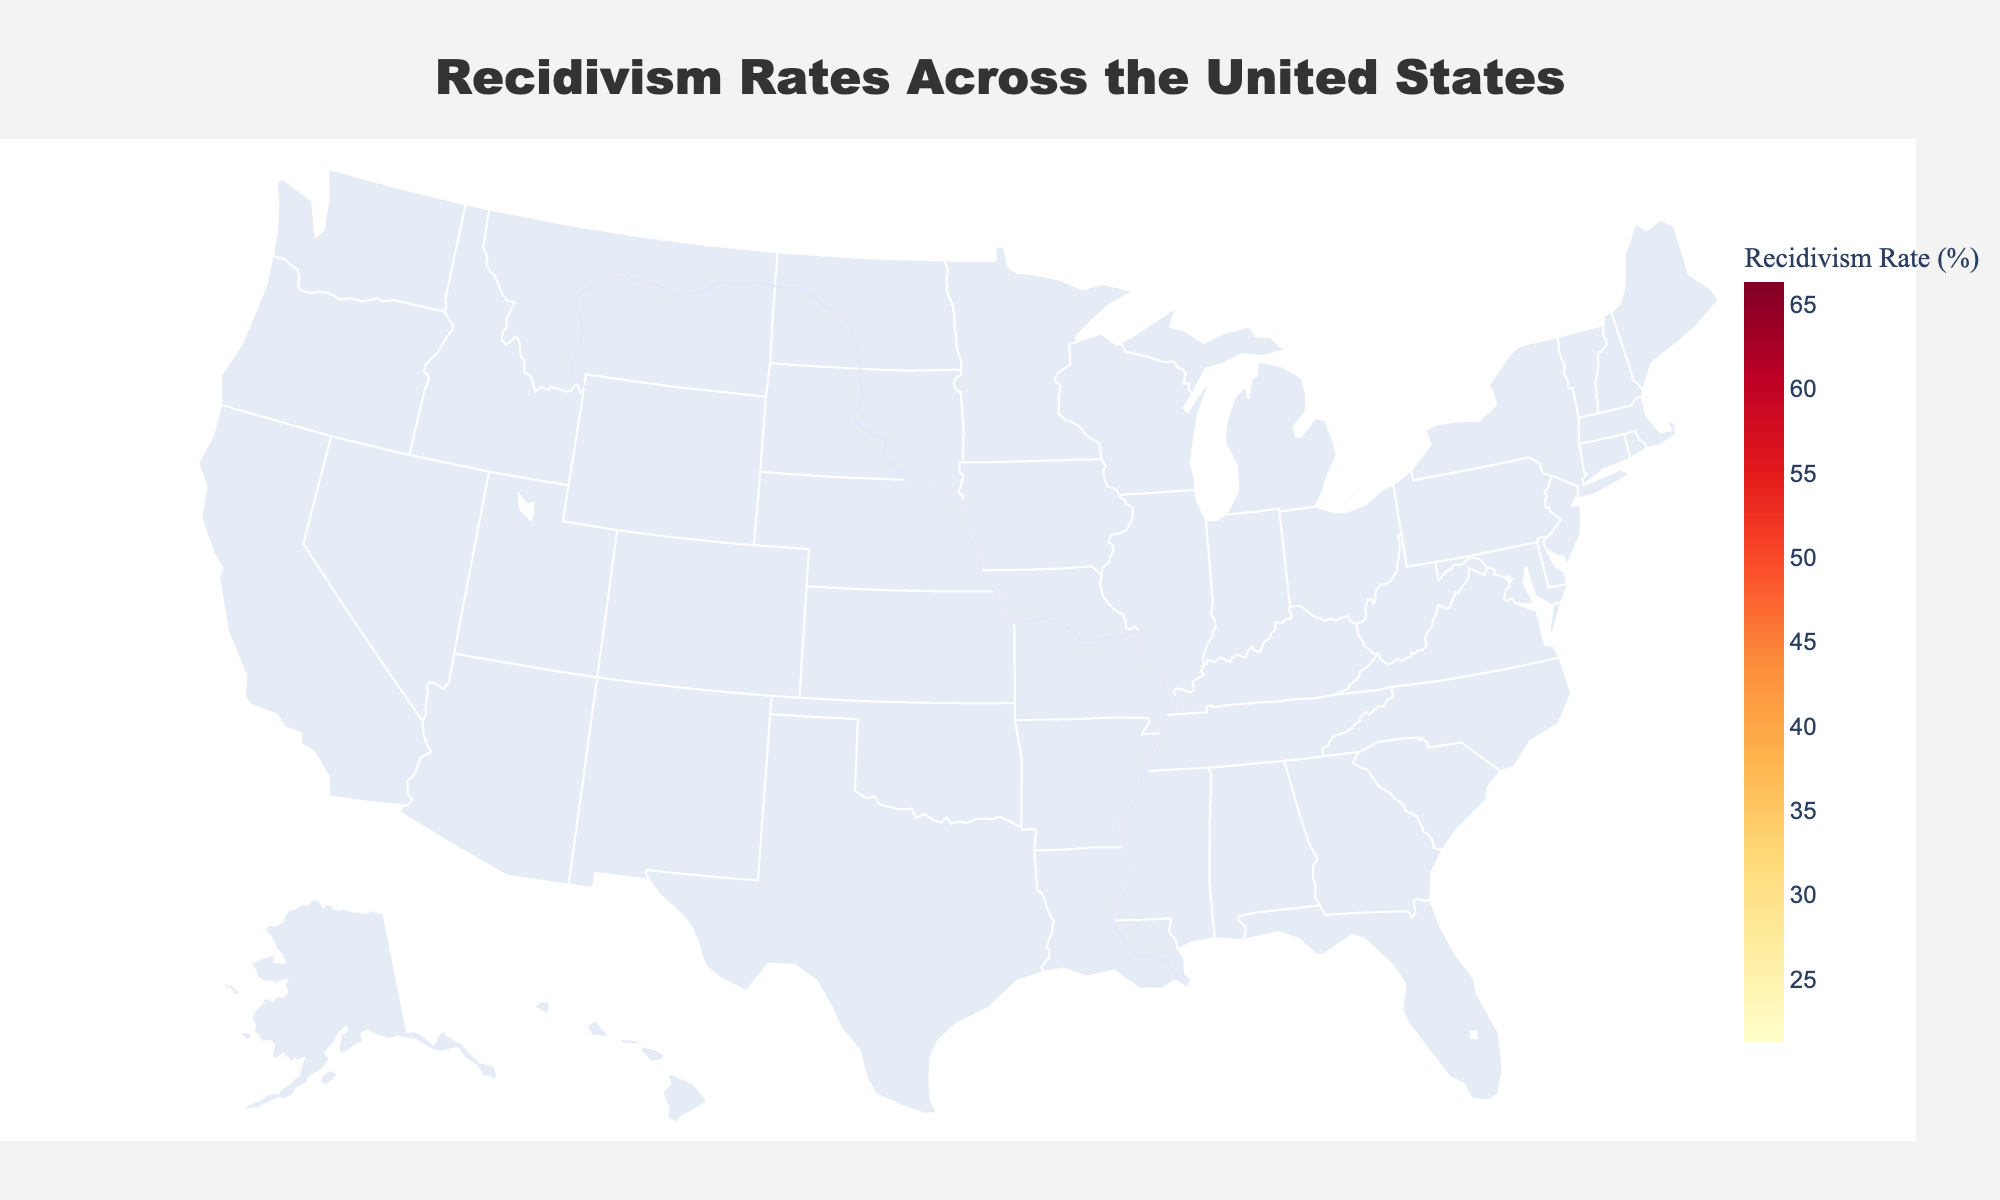Which state has the highest recidivism rate? The figure's color variations indicate that the darker states likely have higher recidivism rates. Alaska is the darkest, and the hover text confirms its recidivism rate is 66.4%.
Answer: Alaska Which state has the lowest recidivism rate? The figure's color variations indicate that the lighter states likely have lower recidivism rates. Texas appears the lightest, with a hover text confirming its recidivism rate of 21.4%.
Answer: Texas What is the average recidivism rate across all states shown in the figure? Sum all recidivism rates and divide by the number of states (50): (31.2 + 66.4 + ...) / 50 = 39.1%.
Answer: 39.1% How many states have a recidivism rate higher than 50%? By identifying states with recidivism rates above 50% from the data, we can count that Alaska, Connecticut, Delaware, Rhode Island, Tennessee, and Utah meet this criterion.
Answer: 6 Which states have a recidivism rate between 30% and 40%? From the color gradient and hover text, states that fall within this range are Alabama, Arizona, Idaho, Indiana, Iowa, Kansas, Louisiana, Mississippi, Nebraska, New Jersey, and Wyoming.
Answer: 11 Which states have a lower recidivism rate than Florida? Identify states with recidivism rates below Florida's 25.4%, which are Texas, South Carolina, Virginia, Minnesota, Oklahoma, and West Virginia.
Answer: 6 Compare the recidivism rate of California and Texas. California's recidivism rate is 44.6%, while Texas's rate is 21.4%. California has a much higher rate.
Answer: California > Texas Which region of the US tends to have higher recidivism rates? By observing the darker regions, higher recidivism rates are concentrated in the northeast and some parts of the west, like Connecticut, Delaware, and Alaska.
Answer: Northeast and some parts of the west What is the difference in recidivism rate between the state with the highest rate and the state with the lowest rate? The highest is Alaska at 66.4%, and the lowest is Texas at 21.4%. The difference is 66.4% - 21.4% = 45%.
Answer: 45% How does the recidivism rate in the Midwest compare to the national average? States in the Midwest (e.g., Illinois, Indiana, Iowa, etc.) average around 39.6% (close to the national average of 39.1%). Specific comparisons of individual states like Iowa (37.8%) and Illinois (43%) are near the national average.
Answer: Similar to the national average 